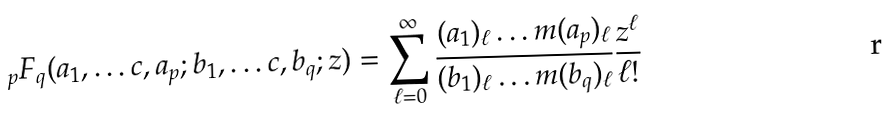Convert formula to latex. <formula><loc_0><loc_0><loc_500><loc_500>{ } _ { p } F _ { q } ( a _ { 1 } , \dots c , a _ { p } ; b _ { 1 } , \dots c , b _ { q } ; z ) = \sum _ { \ell = 0 } ^ { \infty } \frac { ( a _ { 1 } ) _ { \ell } \dots m ( a _ { p } ) _ { \ell } } { ( b _ { 1 } ) _ { \ell } \dots m ( b _ { q } ) _ { \ell } } \frac { z ^ { \ell } } { \ell ! }</formula> 